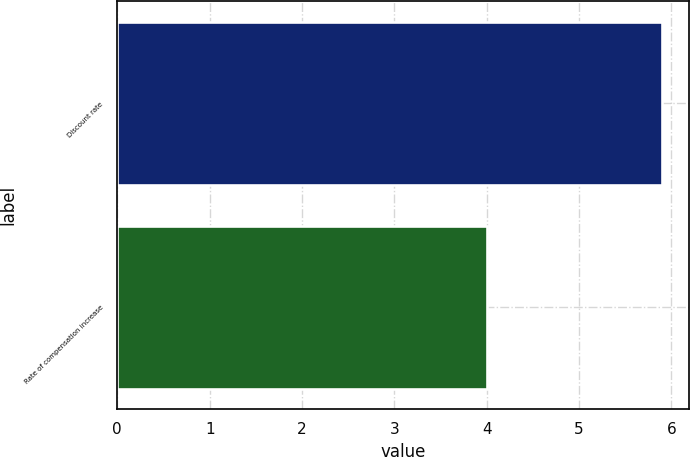Convert chart to OTSL. <chart><loc_0><loc_0><loc_500><loc_500><bar_chart><fcel>Discount rate<fcel>Rate of compensation increase<nl><fcel>5.9<fcel>4<nl></chart> 